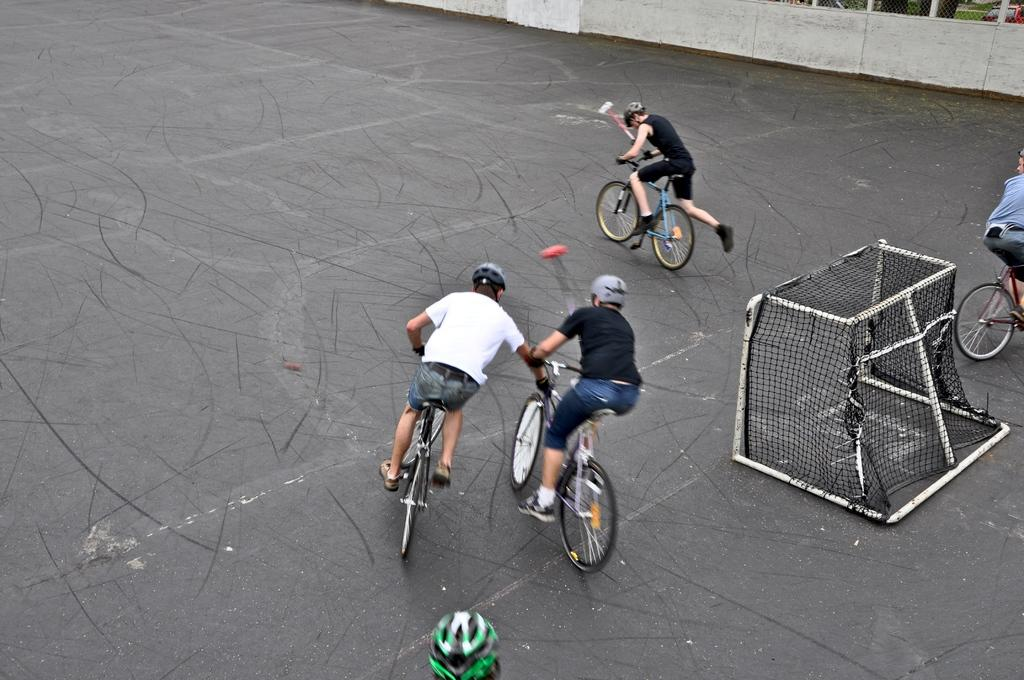How many people are in the image? There are four persons in the image. What activity are the persons engaged in? The persons are doing cycling. What can be seen in the background of the image? The image shows a road. What safety precaution are the cyclists taking? All the persons are wearing helmets. What type of record can be seen being played by the cyclists in the image? There is no record or any indication of music playing in the image; the persons are cycling on a road. 